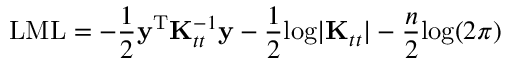<formula> <loc_0><loc_0><loc_500><loc_500>L M L = - \frac { 1 } { 2 } y ^ { T } K _ { t t } ^ { - 1 } y - \frac { 1 } { 2 } \log | K _ { t t } | - \frac { n } { 2 } \log ( 2 \pi )</formula> 